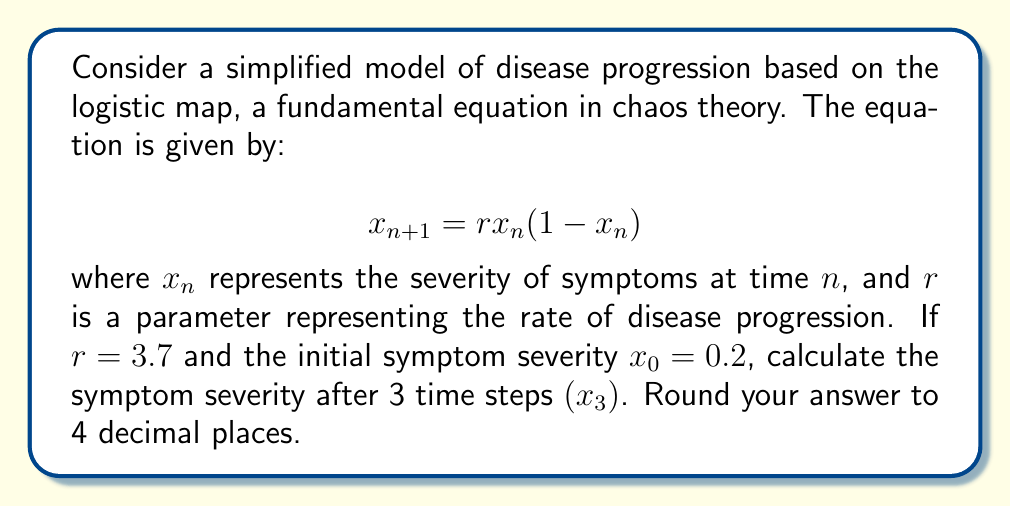Show me your answer to this math problem. Let's approach this step-by-step:

1) We start with the logistic map equation:
   $$ x_{n+1} = rx_n(1-x_n) $$

2) We're given that $r=3.7$ and $x_0=0.2$. We need to calculate $x_3$, which means we need to iterate the equation 3 times.

3) First iteration (calculating $x_1$):
   $$ x_1 = 3.7 * 0.2 * (1-0.2) = 3.7 * 0.2 * 0.8 = 0.592 $$

4) Second iteration (calculating $x_2$):
   $$ x_2 = 3.7 * 0.592 * (1-0.592) = 3.7 * 0.592 * 0.408 = 0.8929344 $$

5) Third iteration (calculating $x_3$):
   $$ x_3 = 3.7 * 0.8929344 * (1-0.8929344) = 3.7 * 0.8929344 * 0.1070656 = 0.3540 $$

6) Rounding to 4 decimal places, we get 0.3540.

This demonstrates how a simple deterministic equation can lead to complex, seemingly unpredictable behavior over time, which is a key concept in chaos theory. In the context of disease progression, this could represent how small changes in initial conditions or parameters can lead to significantly different outcomes, making long-term predictions challenging.
Answer: 0.3540 